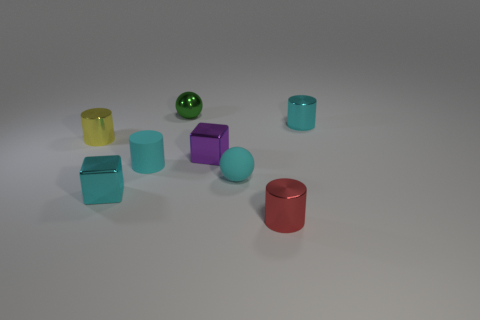Subtract all yellow metal cylinders. How many cylinders are left? 3 Subtract all brown blocks. How many cyan cylinders are left? 2 Subtract all yellow cylinders. How many cylinders are left? 3 Add 2 tiny cyan objects. How many objects exist? 10 Subtract all purple cylinders. Subtract all gray blocks. How many cylinders are left? 4 Subtract all small rubber things. Subtract all cyan shiny cubes. How many objects are left? 5 Add 4 small cyan shiny cylinders. How many small cyan shiny cylinders are left? 5 Add 7 small green metallic things. How many small green metallic things exist? 8 Subtract 1 red cylinders. How many objects are left? 7 